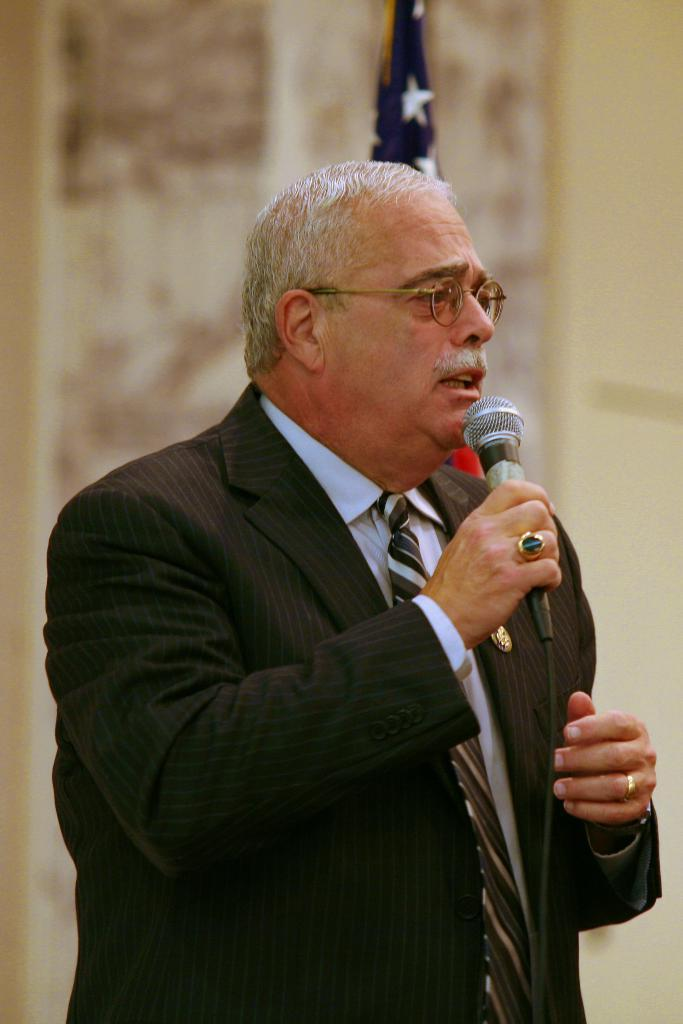What is the main subject of the image? There is a person in the image. What is the person holding in the image? The person is holding a microphone. What is the person doing with their mouth in the image? The person's mouth is open. What grade does the chair receive in the image? There is no chair present in the image, so it cannot receive a grade. 